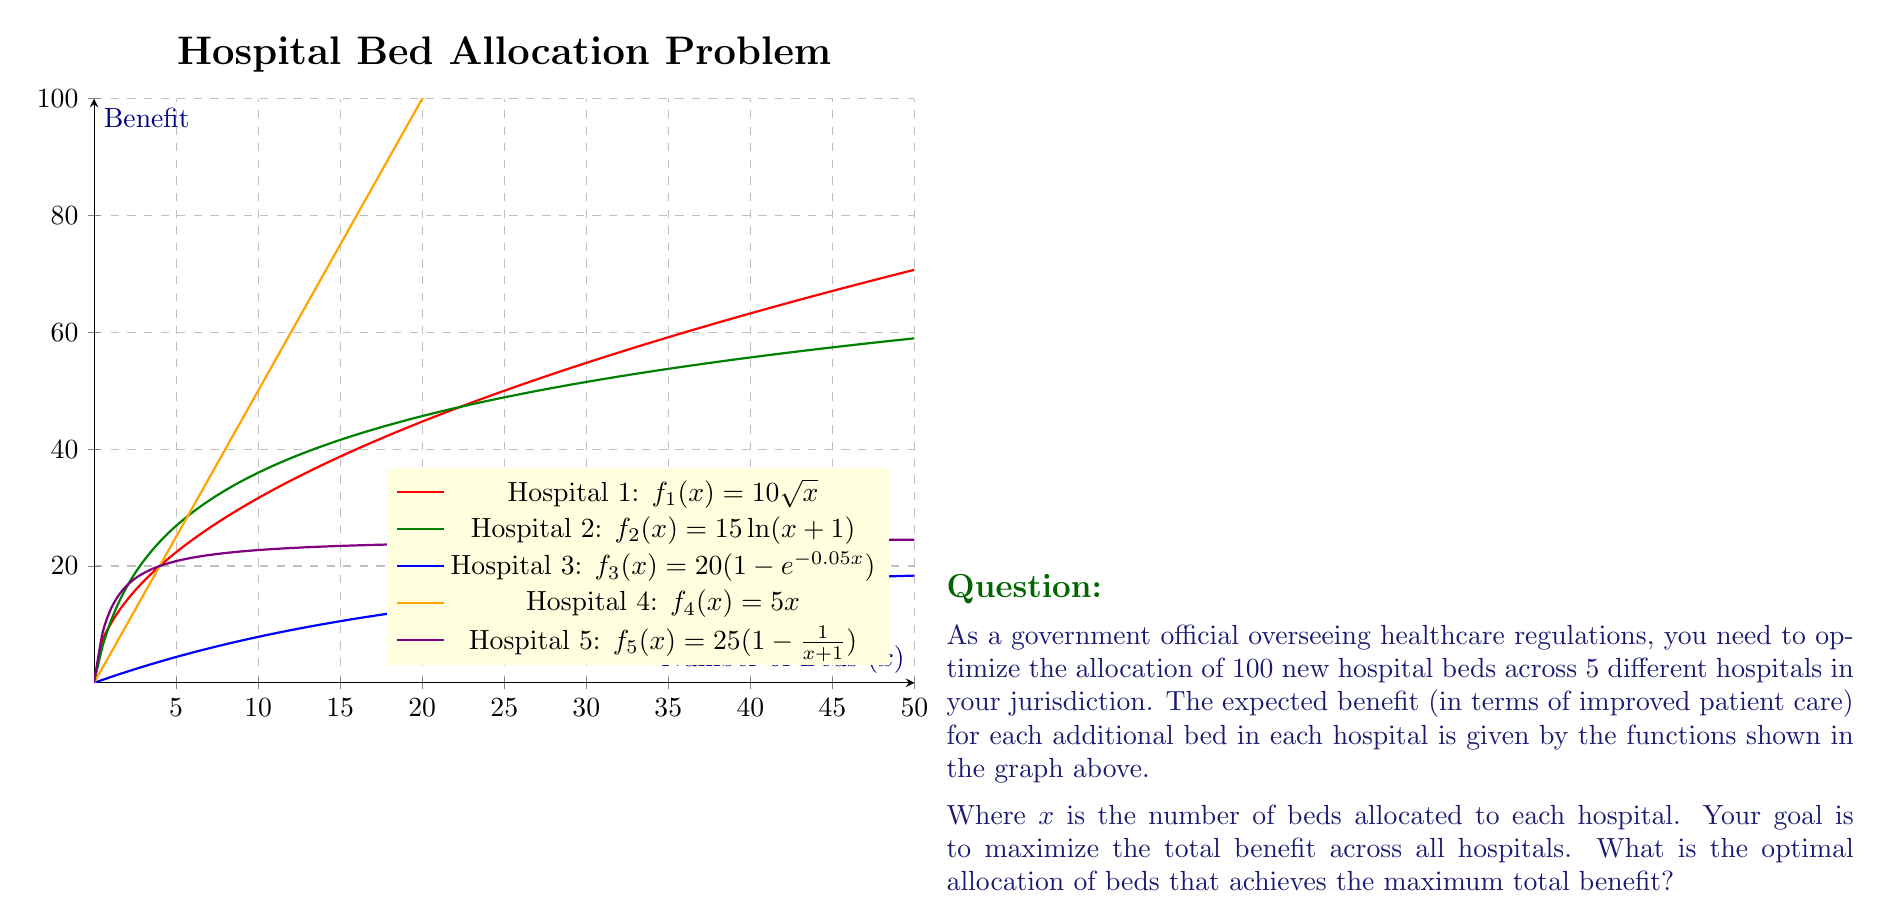Solve this math problem. To solve this optimization problem, we need to use the method of Lagrange multipliers, as we have a constrained optimization problem with the constraint that the total number of beds must sum to 100.

Let's define our Lagrangian function:

$$L(x_1, x_2, x_3, x_4, x_5, \lambda) = f_1(x_1) + f_2(x_2) + f_3(x_3) + f_4(x_4) + f_5(x_5) - \lambda(x_1 + x_2 + x_3 + x_4 + x_5 - 100)$$

Now, we need to take partial derivatives with respect to each variable and set them equal to zero:

1) $\frac{\partial L}{\partial x_1} = 5x_1^{-1/2} - \lambda = 0$
2) $\frac{\partial L}{\partial x_2} = \frac{15}{x_2+1} - \lambda = 0$
3) $\frac{\partial L}{\partial x_3} = e^{-0.05x_3} - \lambda = 0$
4) $\frac{\partial L}{\partial x_4} = 5 - \lambda = 0$
5) $\frac{\partial L}{\partial x_5} = \frac{25}{(x_5+1)^2} - \lambda = 0$
6) $\frac{\partial L}{\partial \lambda} = x_1 + x_2 + x_3 + x_4 + x_5 - 100 = 0$

From equation 4, we can see that $\lambda = 5$. Substituting this into the other equations:

1) $x_1 = 25$
2) $x_2 = 2$
3) $x_3 = 20\ln(4) \approx 27.73$
4) $x_4 = 5$
5) $x_5 = \sqrt{5} - 1 \approx 1.24$

Rounding to the nearest integer (as we can't allocate fractional beds) and adjusting to ensure the total is exactly 100, we get:

$x_1 = 25$, $x_2 = 2$, $x_3 = 28$, $x_4 = 44$, $x_5 = 1$
Answer: (25, 2, 28, 44, 1) 